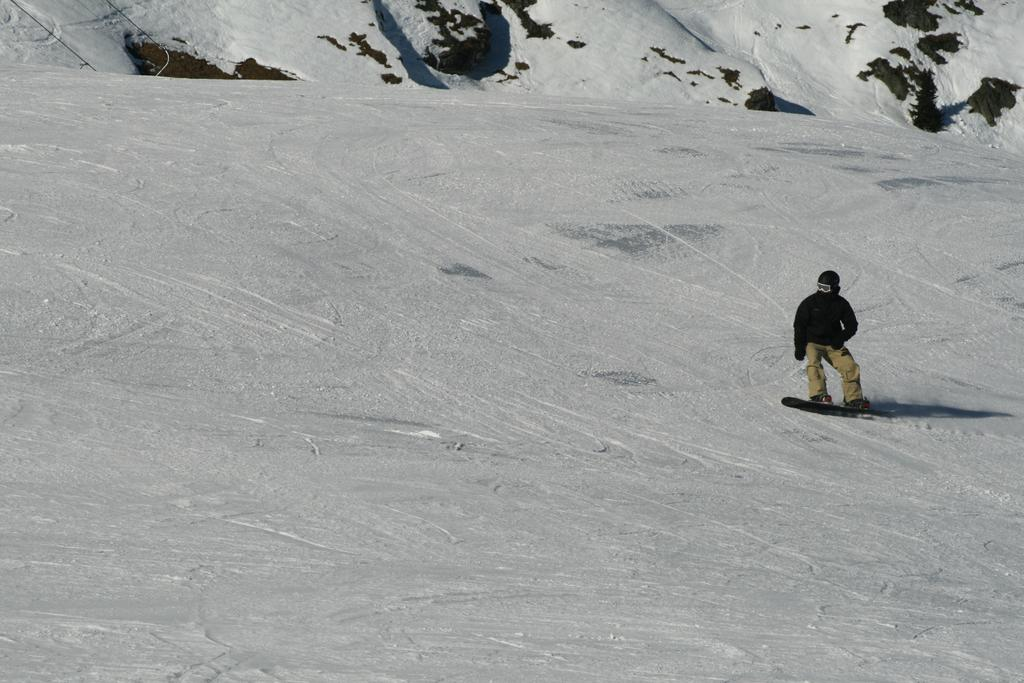Who is present in the image? There is a man in the image. What is the man wearing on his hands and head? The man is wearing gloves and a helmet. What activity is the man engaged in? The man is skating on the ice. What can be seen in the background of the image? There are rocks in the background of the image. What type of vessel is the man using to navigate through the rainstorm in the image? There is no vessel or rainstorm present in the image; the man is skating on the ice. How many pizzas can be seen in the image? There are no pizzas present in the image. 